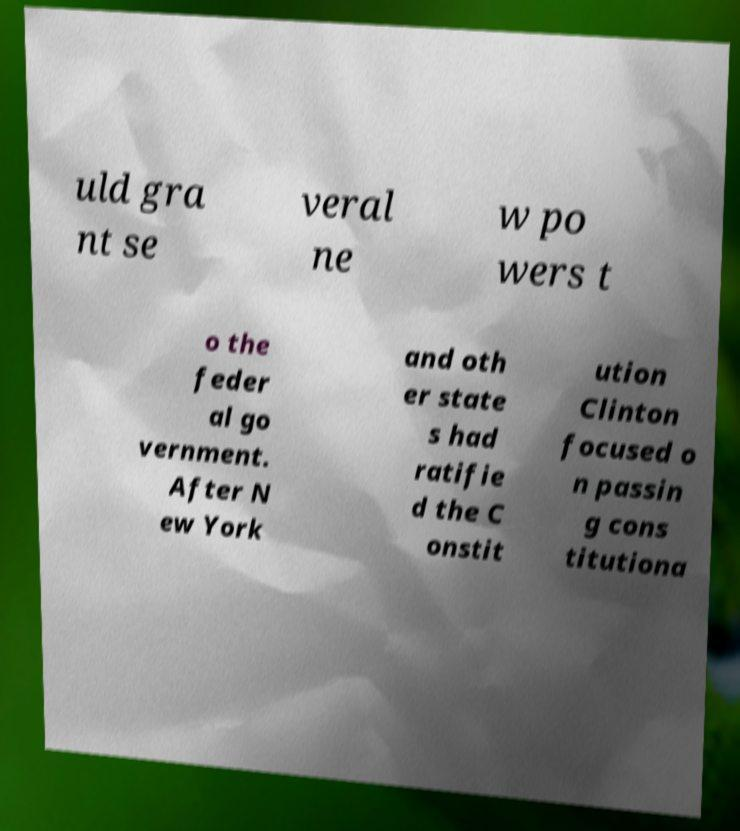Can you accurately transcribe the text from the provided image for me? uld gra nt se veral ne w po wers t o the feder al go vernment. After N ew York and oth er state s had ratifie d the C onstit ution Clinton focused o n passin g cons titutiona 